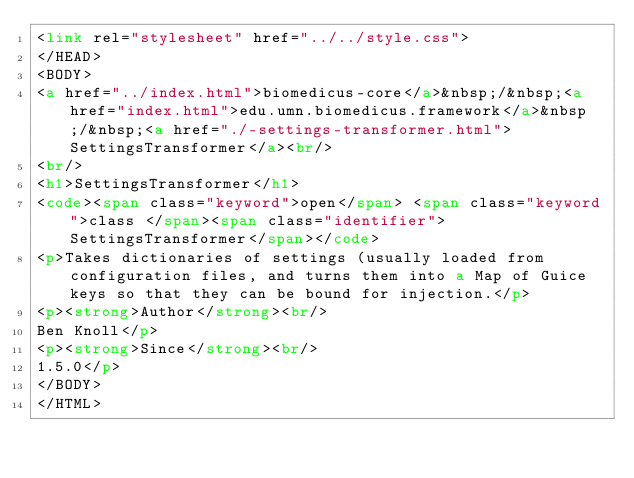Convert code to text. <code><loc_0><loc_0><loc_500><loc_500><_HTML_><link rel="stylesheet" href="../../style.css">
</HEAD>
<BODY>
<a href="../index.html">biomedicus-core</a>&nbsp;/&nbsp;<a href="index.html">edu.umn.biomedicus.framework</a>&nbsp;/&nbsp;<a href="./-settings-transformer.html">SettingsTransformer</a><br/>
<br/>
<h1>SettingsTransformer</h1>
<code><span class="keyword">open</span> <span class="keyword">class </span><span class="identifier">SettingsTransformer</span></code>
<p>Takes dictionaries of settings (usually loaded from configuration files, and turns them into a Map of Guice keys so that they can be bound for injection.</p>
<p><strong>Author</strong><br/>
Ben Knoll</p>
<p><strong>Since</strong><br/>
1.5.0</p>
</BODY>
</HTML>
</code> 